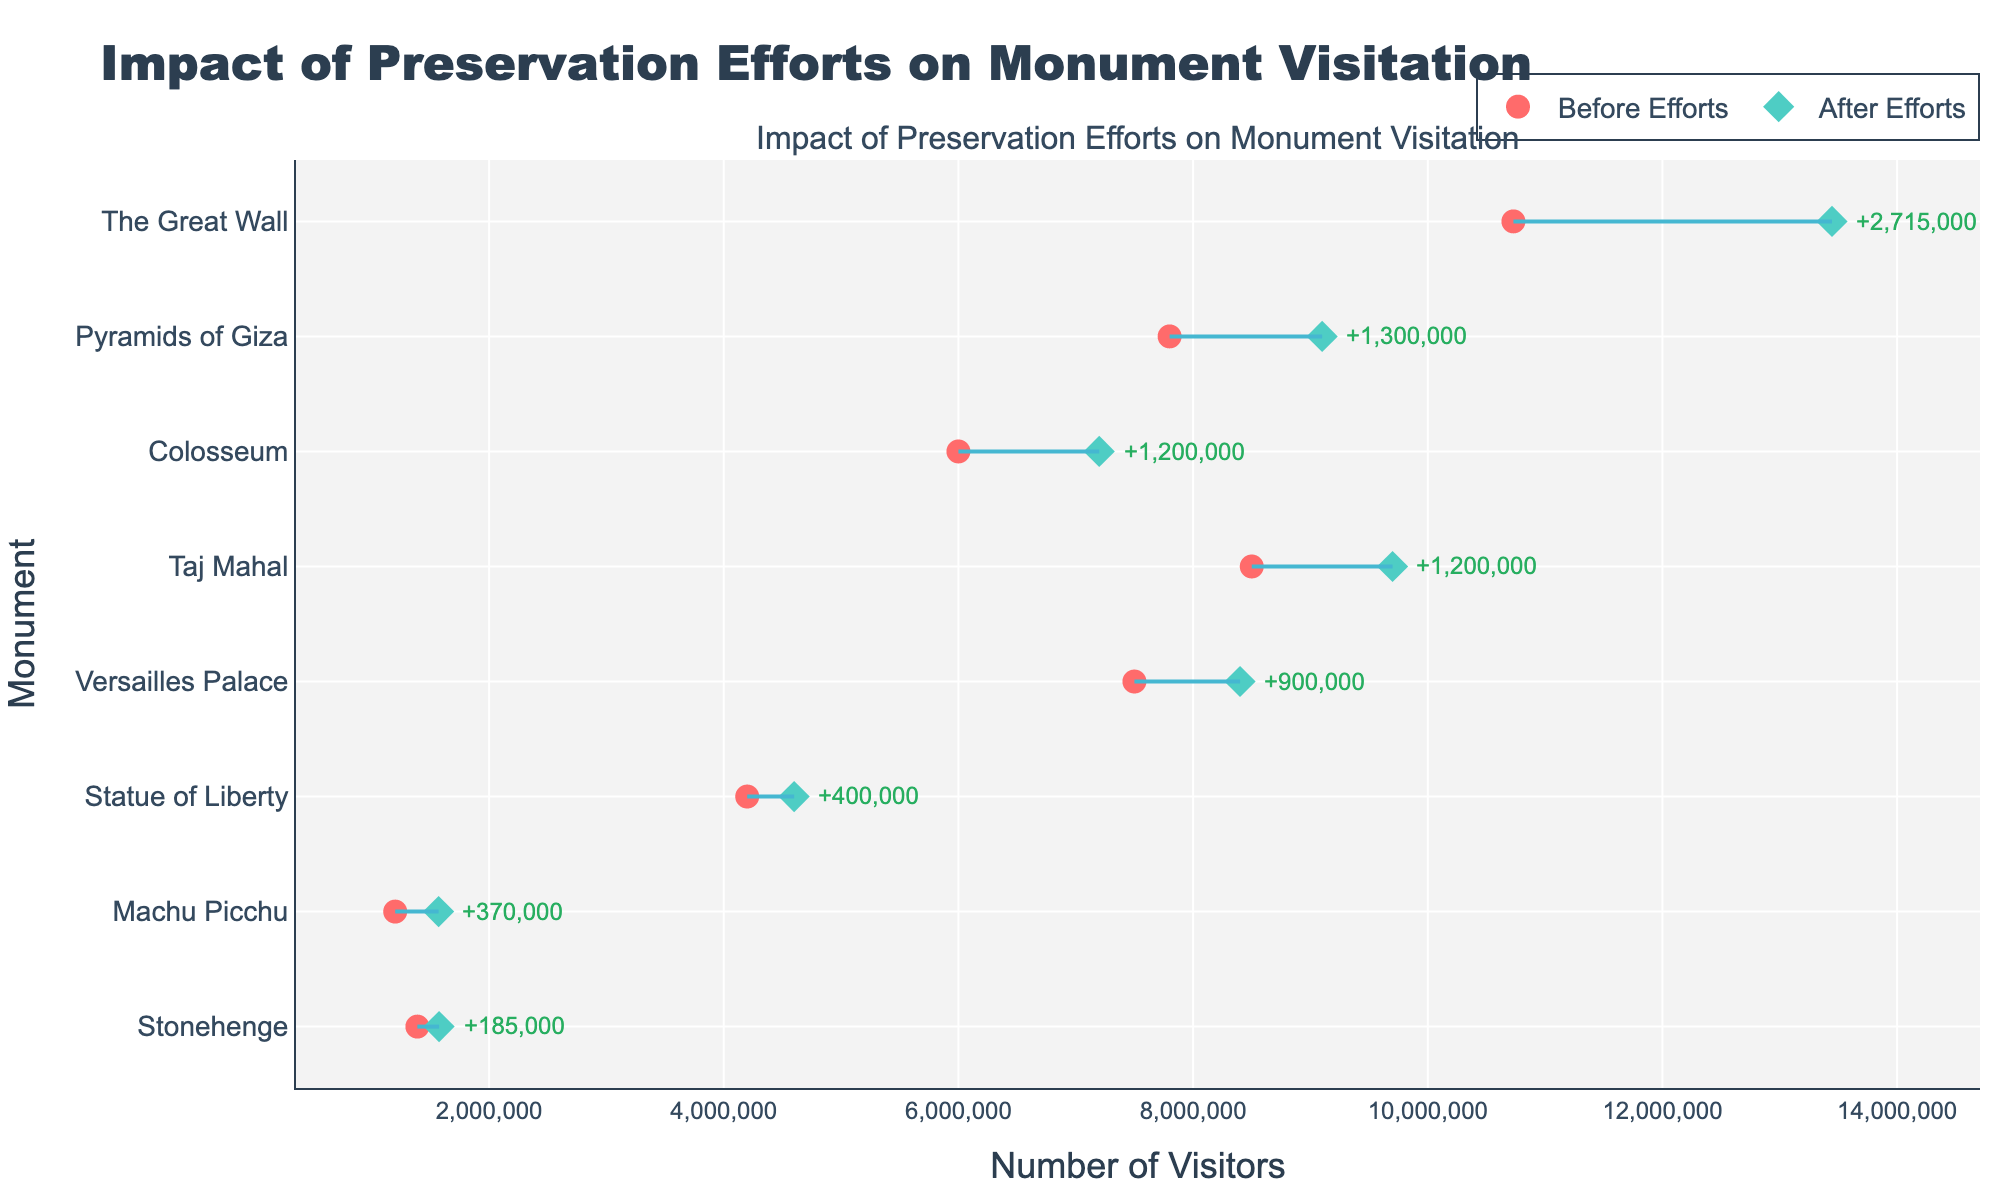Which monument had the highest increase in visitors after preservation efforts? Look for the monument with the biggest difference between visitors before and after preservation. The Great Wall in China had the highest difference, with an increase of 2,715,000 visitors.
Answer: The Great Wall What's the total number of visitors after preservation efforts for all monuments combined? Sum the 'Visitors_AF (After Efforts)' values of all the monuments. The total number of visitors is 13,445,000 (The Great Wall) + 9,100,000 (Pyramids of Giza) + 9,700,000 (Taj Mahal) + 7,200,000 (Colosseum) + 1,570,000 (Machu Picchu) + 4,600,000 (Statue of Liberty) + 1,574,000 (Stonehenge) + 8,400,000 (Versailles Palace) = 55,589,000.
Answer: 55,589,000 Which monument had the smallest increase in visitors after preservation efforts? Compare the differences between visitors before and after preservation. The Statue of Liberty had the smallest increase, with 400,000 additional visitors.
Answer: Statue of Liberty What is the average increase in the number of visitors across all monuments? Calculate the average increase in visitors by first summing the differences and then dividing by the number of monuments. The total increase is 2,715,000 (The Great Wall) + 1,300,000 (Pyramids of Giza) + 1,200,000 (Taj Mahal) + 1,200,000 (Colosseum) + 370,000 (Machu Picchu) + 400,000 (Statue of Liberty) + 185,000 (Stonehenge) + 900,000 (Versailles Palace) = 8,270,000. The number of monuments is 8, so the average increase is 8,270,000 / 8 = 1,033,750.
Answer: 1,033,750 Which monument had the closest visitor numbers before and after preservation? Look for the smallest absolute difference between 'Visitors_BE (Before Efforts)' and 'Visitors_AF (After Efforts)'. Stonehenge had the smallest difference with a change of 185,000 visitors.
Answer: Stonehenge 